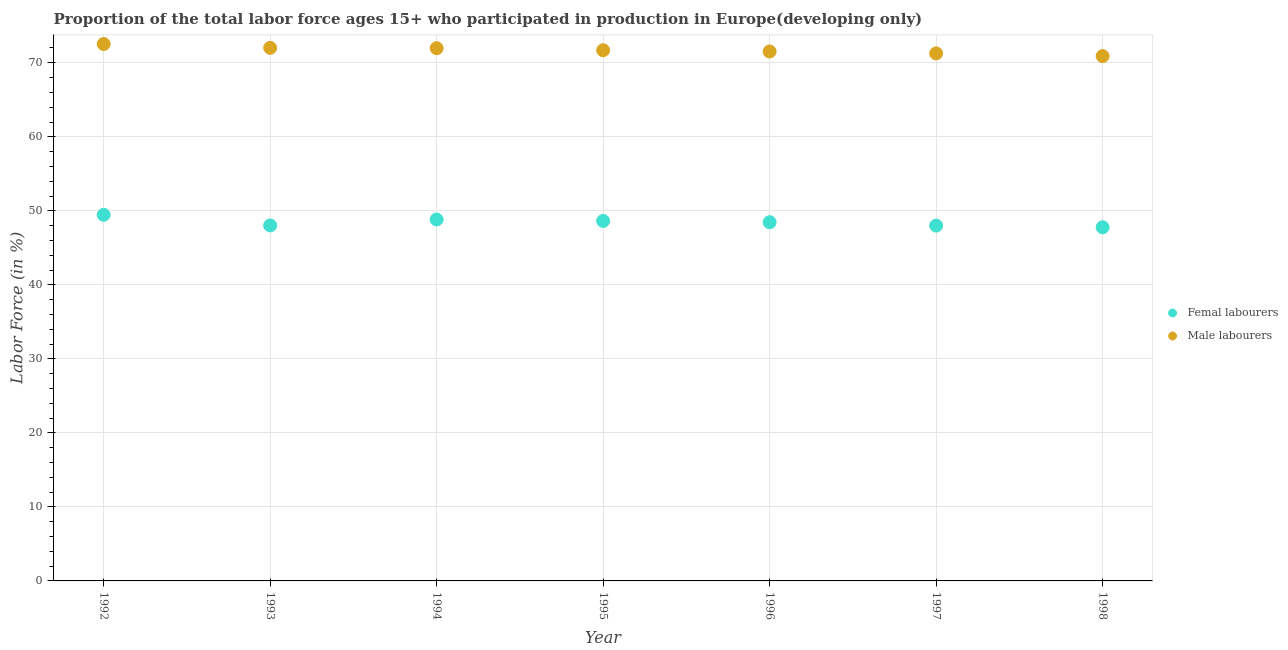How many different coloured dotlines are there?
Ensure brevity in your answer.  2. Is the number of dotlines equal to the number of legend labels?
Your answer should be very brief. Yes. What is the percentage of female labor force in 1997?
Keep it short and to the point. 48. Across all years, what is the maximum percentage of male labour force?
Offer a very short reply. 72.53. Across all years, what is the minimum percentage of female labor force?
Ensure brevity in your answer.  47.78. What is the total percentage of female labor force in the graph?
Offer a terse response. 339.19. What is the difference between the percentage of male labour force in 1992 and that in 1994?
Offer a very short reply. 0.56. What is the difference between the percentage of female labor force in 1997 and the percentage of male labour force in 1995?
Your answer should be compact. -23.69. What is the average percentage of male labour force per year?
Provide a short and direct response. 71.7. In the year 1997, what is the difference between the percentage of male labour force and percentage of female labor force?
Give a very brief answer. 23.27. What is the ratio of the percentage of female labor force in 1992 to that in 1994?
Your answer should be compact. 1.01. Is the percentage of male labour force in 1992 less than that in 1995?
Make the answer very short. No. Is the difference between the percentage of female labor force in 1992 and 1998 greater than the difference between the percentage of male labour force in 1992 and 1998?
Make the answer very short. Yes. What is the difference between the highest and the second highest percentage of female labor force?
Ensure brevity in your answer.  0.63. What is the difference between the highest and the lowest percentage of female labor force?
Provide a succinct answer. 1.68. In how many years, is the percentage of female labor force greater than the average percentage of female labor force taken over all years?
Your answer should be compact. 4. Is the sum of the percentage of male labour force in 1992 and 1998 greater than the maximum percentage of female labor force across all years?
Provide a short and direct response. Yes. Is the percentage of female labor force strictly greater than the percentage of male labour force over the years?
Offer a terse response. No. Is the percentage of female labor force strictly less than the percentage of male labour force over the years?
Give a very brief answer. Yes. How many dotlines are there?
Your response must be concise. 2. How many years are there in the graph?
Keep it short and to the point. 7. What is the difference between two consecutive major ticks on the Y-axis?
Ensure brevity in your answer.  10. Are the values on the major ticks of Y-axis written in scientific E-notation?
Make the answer very short. No. Does the graph contain any zero values?
Provide a short and direct response. No. Does the graph contain grids?
Provide a succinct answer. Yes. Where does the legend appear in the graph?
Keep it short and to the point. Center right. What is the title of the graph?
Offer a terse response. Proportion of the total labor force ages 15+ who participated in production in Europe(developing only). What is the Labor Force (in %) of Femal labourers in 1992?
Offer a terse response. 49.46. What is the Labor Force (in %) of Male labourers in 1992?
Your answer should be very brief. 72.53. What is the Labor Force (in %) in Femal labourers in 1993?
Make the answer very short. 48.03. What is the Labor Force (in %) of Male labourers in 1993?
Your answer should be very brief. 72.02. What is the Labor Force (in %) in Femal labourers in 1994?
Offer a very short reply. 48.83. What is the Labor Force (in %) of Male labourers in 1994?
Offer a very short reply. 71.97. What is the Labor Force (in %) in Femal labourers in 1995?
Ensure brevity in your answer.  48.63. What is the Labor Force (in %) of Male labourers in 1995?
Ensure brevity in your answer.  71.7. What is the Labor Force (in %) of Femal labourers in 1996?
Provide a short and direct response. 48.46. What is the Labor Force (in %) of Male labourers in 1996?
Give a very brief answer. 71.53. What is the Labor Force (in %) of Femal labourers in 1997?
Keep it short and to the point. 48. What is the Labor Force (in %) of Male labourers in 1997?
Offer a terse response. 71.27. What is the Labor Force (in %) in Femal labourers in 1998?
Provide a succinct answer. 47.78. What is the Labor Force (in %) in Male labourers in 1998?
Provide a short and direct response. 70.9. Across all years, what is the maximum Labor Force (in %) in Femal labourers?
Your response must be concise. 49.46. Across all years, what is the maximum Labor Force (in %) of Male labourers?
Your response must be concise. 72.53. Across all years, what is the minimum Labor Force (in %) of Femal labourers?
Offer a very short reply. 47.78. Across all years, what is the minimum Labor Force (in %) in Male labourers?
Offer a very short reply. 70.9. What is the total Labor Force (in %) in Femal labourers in the graph?
Ensure brevity in your answer.  339.19. What is the total Labor Force (in %) in Male labourers in the graph?
Provide a short and direct response. 501.93. What is the difference between the Labor Force (in %) of Femal labourers in 1992 and that in 1993?
Your answer should be very brief. 1.44. What is the difference between the Labor Force (in %) of Male labourers in 1992 and that in 1993?
Give a very brief answer. 0.51. What is the difference between the Labor Force (in %) in Femal labourers in 1992 and that in 1994?
Give a very brief answer. 0.63. What is the difference between the Labor Force (in %) in Male labourers in 1992 and that in 1994?
Provide a short and direct response. 0.56. What is the difference between the Labor Force (in %) in Femal labourers in 1992 and that in 1995?
Provide a succinct answer. 0.83. What is the difference between the Labor Force (in %) in Male labourers in 1992 and that in 1995?
Keep it short and to the point. 0.84. What is the difference between the Labor Force (in %) in Femal labourers in 1992 and that in 1996?
Your response must be concise. 1. What is the difference between the Labor Force (in %) of Male labourers in 1992 and that in 1996?
Keep it short and to the point. 1.01. What is the difference between the Labor Force (in %) of Femal labourers in 1992 and that in 1997?
Provide a short and direct response. 1.46. What is the difference between the Labor Force (in %) of Male labourers in 1992 and that in 1997?
Keep it short and to the point. 1.26. What is the difference between the Labor Force (in %) of Femal labourers in 1992 and that in 1998?
Your response must be concise. 1.68. What is the difference between the Labor Force (in %) of Male labourers in 1992 and that in 1998?
Provide a short and direct response. 1.63. What is the difference between the Labor Force (in %) of Femal labourers in 1993 and that in 1994?
Your response must be concise. -0.81. What is the difference between the Labor Force (in %) in Male labourers in 1993 and that in 1994?
Your answer should be compact. 0.05. What is the difference between the Labor Force (in %) in Femal labourers in 1993 and that in 1995?
Ensure brevity in your answer.  -0.61. What is the difference between the Labor Force (in %) in Male labourers in 1993 and that in 1995?
Offer a terse response. 0.33. What is the difference between the Labor Force (in %) of Femal labourers in 1993 and that in 1996?
Your response must be concise. -0.43. What is the difference between the Labor Force (in %) of Male labourers in 1993 and that in 1996?
Your response must be concise. 0.49. What is the difference between the Labor Force (in %) of Femal labourers in 1993 and that in 1997?
Keep it short and to the point. 0.02. What is the difference between the Labor Force (in %) in Male labourers in 1993 and that in 1997?
Give a very brief answer. 0.75. What is the difference between the Labor Force (in %) in Femal labourers in 1993 and that in 1998?
Provide a short and direct response. 0.25. What is the difference between the Labor Force (in %) of Male labourers in 1993 and that in 1998?
Your answer should be very brief. 1.12. What is the difference between the Labor Force (in %) of Femal labourers in 1994 and that in 1995?
Your answer should be compact. 0.2. What is the difference between the Labor Force (in %) in Male labourers in 1994 and that in 1995?
Keep it short and to the point. 0.28. What is the difference between the Labor Force (in %) in Femal labourers in 1994 and that in 1996?
Ensure brevity in your answer.  0.37. What is the difference between the Labor Force (in %) in Male labourers in 1994 and that in 1996?
Keep it short and to the point. 0.45. What is the difference between the Labor Force (in %) of Femal labourers in 1994 and that in 1997?
Keep it short and to the point. 0.83. What is the difference between the Labor Force (in %) of Male labourers in 1994 and that in 1997?
Your answer should be very brief. 0.7. What is the difference between the Labor Force (in %) in Femal labourers in 1994 and that in 1998?
Provide a succinct answer. 1.05. What is the difference between the Labor Force (in %) of Male labourers in 1994 and that in 1998?
Offer a very short reply. 1.07. What is the difference between the Labor Force (in %) in Femal labourers in 1995 and that in 1996?
Offer a very short reply. 0.17. What is the difference between the Labor Force (in %) in Male labourers in 1995 and that in 1996?
Your answer should be very brief. 0.17. What is the difference between the Labor Force (in %) in Femal labourers in 1995 and that in 1997?
Offer a very short reply. 0.63. What is the difference between the Labor Force (in %) in Male labourers in 1995 and that in 1997?
Offer a very short reply. 0.42. What is the difference between the Labor Force (in %) of Femal labourers in 1995 and that in 1998?
Your response must be concise. 0.85. What is the difference between the Labor Force (in %) in Male labourers in 1995 and that in 1998?
Make the answer very short. 0.79. What is the difference between the Labor Force (in %) of Femal labourers in 1996 and that in 1997?
Your answer should be compact. 0.46. What is the difference between the Labor Force (in %) in Male labourers in 1996 and that in 1997?
Provide a short and direct response. 0.25. What is the difference between the Labor Force (in %) of Femal labourers in 1996 and that in 1998?
Provide a short and direct response. 0.68. What is the difference between the Labor Force (in %) in Male labourers in 1996 and that in 1998?
Keep it short and to the point. 0.62. What is the difference between the Labor Force (in %) in Femal labourers in 1997 and that in 1998?
Make the answer very short. 0.23. What is the difference between the Labor Force (in %) in Male labourers in 1997 and that in 1998?
Ensure brevity in your answer.  0.37. What is the difference between the Labor Force (in %) of Femal labourers in 1992 and the Labor Force (in %) of Male labourers in 1993?
Make the answer very short. -22.56. What is the difference between the Labor Force (in %) of Femal labourers in 1992 and the Labor Force (in %) of Male labourers in 1994?
Provide a succinct answer. -22.51. What is the difference between the Labor Force (in %) of Femal labourers in 1992 and the Labor Force (in %) of Male labourers in 1995?
Provide a succinct answer. -22.23. What is the difference between the Labor Force (in %) of Femal labourers in 1992 and the Labor Force (in %) of Male labourers in 1996?
Your answer should be compact. -22.07. What is the difference between the Labor Force (in %) of Femal labourers in 1992 and the Labor Force (in %) of Male labourers in 1997?
Your answer should be compact. -21.81. What is the difference between the Labor Force (in %) in Femal labourers in 1992 and the Labor Force (in %) in Male labourers in 1998?
Your answer should be compact. -21.44. What is the difference between the Labor Force (in %) in Femal labourers in 1993 and the Labor Force (in %) in Male labourers in 1994?
Offer a terse response. -23.95. What is the difference between the Labor Force (in %) of Femal labourers in 1993 and the Labor Force (in %) of Male labourers in 1995?
Provide a succinct answer. -23.67. What is the difference between the Labor Force (in %) in Femal labourers in 1993 and the Labor Force (in %) in Male labourers in 1996?
Provide a succinct answer. -23.5. What is the difference between the Labor Force (in %) of Femal labourers in 1993 and the Labor Force (in %) of Male labourers in 1997?
Make the answer very short. -23.25. What is the difference between the Labor Force (in %) of Femal labourers in 1993 and the Labor Force (in %) of Male labourers in 1998?
Your answer should be very brief. -22.88. What is the difference between the Labor Force (in %) of Femal labourers in 1994 and the Labor Force (in %) of Male labourers in 1995?
Your answer should be compact. -22.86. What is the difference between the Labor Force (in %) of Femal labourers in 1994 and the Labor Force (in %) of Male labourers in 1996?
Offer a very short reply. -22.7. What is the difference between the Labor Force (in %) in Femal labourers in 1994 and the Labor Force (in %) in Male labourers in 1997?
Offer a very short reply. -22.44. What is the difference between the Labor Force (in %) of Femal labourers in 1994 and the Labor Force (in %) of Male labourers in 1998?
Give a very brief answer. -22.07. What is the difference between the Labor Force (in %) in Femal labourers in 1995 and the Labor Force (in %) in Male labourers in 1996?
Give a very brief answer. -22.9. What is the difference between the Labor Force (in %) in Femal labourers in 1995 and the Labor Force (in %) in Male labourers in 1997?
Your response must be concise. -22.64. What is the difference between the Labor Force (in %) of Femal labourers in 1995 and the Labor Force (in %) of Male labourers in 1998?
Make the answer very short. -22.27. What is the difference between the Labor Force (in %) in Femal labourers in 1996 and the Labor Force (in %) in Male labourers in 1997?
Offer a very short reply. -22.81. What is the difference between the Labor Force (in %) in Femal labourers in 1996 and the Labor Force (in %) in Male labourers in 1998?
Offer a very short reply. -22.44. What is the difference between the Labor Force (in %) of Femal labourers in 1997 and the Labor Force (in %) of Male labourers in 1998?
Your answer should be very brief. -22.9. What is the average Labor Force (in %) of Femal labourers per year?
Keep it short and to the point. 48.46. What is the average Labor Force (in %) in Male labourers per year?
Provide a succinct answer. 71.7. In the year 1992, what is the difference between the Labor Force (in %) in Femal labourers and Labor Force (in %) in Male labourers?
Your response must be concise. -23.07. In the year 1993, what is the difference between the Labor Force (in %) of Femal labourers and Labor Force (in %) of Male labourers?
Your answer should be very brief. -24. In the year 1994, what is the difference between the Labor Force (in %) of Femal labourers and Labor Force (in %) of Male labourers?
Provide a succinct answer. -23.14. In the year 1995, what is the difference between the Labor Force (in %) in Femal labourers and Labor Force (in %) in Male labourers?
Your response must be concise. -23.06. In the year 1996, what is the difference between the Labor Force (in %) of Femal labourers and Labor Force (in %) of Male labourers?
Your answer should be compact. -23.07. In the year 1997, what is the difference between the Labor Force (in %) of Femal labourers and Labor Force (in %) of Male labourers?
Provide a succinct answer. -23.27. In the year 1998, what is the difference between the Labor Force (in %) in Femal labourers and Labor Force (in %) in Male labourers?
Your answer should be compact. -23.13. What is the ratio of the Labor Force (in %) of Femal labourers in 1992 to that in 1993?
Offer a very short reply. 1.03. What is the ratio of the Labor Force (in %) in Male labourers in 1992 to that in 1993?
Your answer should be compact. 1.01. What is the ratio of the Labor Force (in %) in Femal labourers in 1992 to that in 1994?
Ensure brevity in your answer.  1.01. What is the ratio of the Labor Force (in %) in Femal labourers in 1992 to that in 1995?
Offer a terse response. 1.02. What is the ratio of the Labor Force (in %) of Male labourers in 1992 to that in 1995?
Provide a succinct answer. 1.01. What is the ratio of the Labor Force (in %) in Femal labourers in 1992 to that in 1996?
Ensure brevity in your answer.  1.02. What is the ratio of the Labor Force (in %) in Male labourers in 1992 to that in 1996?
Give a very brief answer. 1.01. What is the ratio of the Labor Force (in %) in Femal labourers in 1992 to that in 1997?
Offer a terse response. 1.03. What is the ratio of the Labor Force (in %) in Male labourers in 1992 to that in 1997?
Keep it short and to the point. 1.02. What is the ratio of the Labor Force (in %) in Femal labourers in 1992 to that in 1998?
Give a very brief answer. 1.04. What is the ratio of the Labor Force (in %) in Femal labourers in 1993 to that in 1994?
Provide a succinct answer. 0.98. What is the ratio of the Labor Force (in %) in Femal labourers in 1993 to that in 1995?
Your answer should be compact. 0.99. What is the ratio of the Labor Force (in %) of Male labourers in 1993 to that in 1995?
Offer a terse response. 1. What is the ratio of the Labor Force (in %) of Femal labourers in 1993 to that in 1996?
Offer a terse response. 0.99. What is the ratio of the Labor Force (in %) of Male labourers in 1993 to that in 1997?
Offer a very short reply. 1.01. What is the ratio of the Labor Force (in %) of Male labourers in 1993 to that in 1998?
Offer a very short reply. 1.02. What is the ratio of the Labor Force (in %) in Male labourers in 1994 to that in 1995?
Your answer should be very brief. 1. What is the ratio of the Labor Force (in %) in Femal labourers in 1994 to that in 1996?
Your response must be concise. 1.01. What is the ratio of the Labor Force (in %) of Femal labourers in 1994 to that in 1997?
Make the answer very short. 1.02. What is the ratio of the Labor Force (in %) in Male labourers in 1994 to that in 1997?
Offer a very short reply. 1.01. What is the ratio of the Labor Force (in %) in Femal labourers in 1994 to that in 1998?
Give a very brief answer. 1.02. What is the ratio of the Labor Force (in %) of Male labourers in 1994 to that in 1998?
Give a very brief answer. 1.02. What is the ratio of the Labor Force (in %) of Femal labourers in 1995 to that in 1996?
Ensure brevity in your answer.  1. What is the ratio of the Labor Force (in %) of Femal labourers in 1995 to that in 1997?
Provide a succinct answer. 1.01. What is the ratio of the Labor Force (in %) of Male labourers in 1995 to that in 1997?
Offer a very short reply. 1.01. What is the ratio of the Labor Force (in %) in Femal labourers in 1995 to that in 1998?
Keep it short and to the point. 1.02. What is the ratio of the Labor Force (in %) of Male labourers in 1995 to that in 1998?
Your answer should be very brief. 1.01. What is the ratio of the Labor Force (in %) in Femal labourers in 1996 to that in 1997?
Offer a very short reply. 1.01. What is the ratio of the Labor Force (in %) in Femal labourers in 1996 to that in 1998?
Keep it short and to the point. 1.01. What is the ratio of the Labor Force (in %) of Male labourers in 1996 to that in 1998?
Ensure brevity in your answer.  1.01. What is the ratio of the Labor Force (in %) of Femal labourers in 1997 to that in 1998?
Keep it short and to the point. 1. What is the difference between the highest and the second highest Labor Force (in %) in Femal labourers?
Offer a terse response. 0.63. What is the difference between the highest and the second highest Labor Force (in %) in Male labourers?
Give a very brief answer. 0.51. What is the difference between the highest and the lowest Labor Force (in %) in Femal labourers?
Your answer should be very brief. 1.68. What is the difference between the highest and the lowest Labor Force (in %) in Male labourers?
Ensure brevity in your answer.  1.63. 